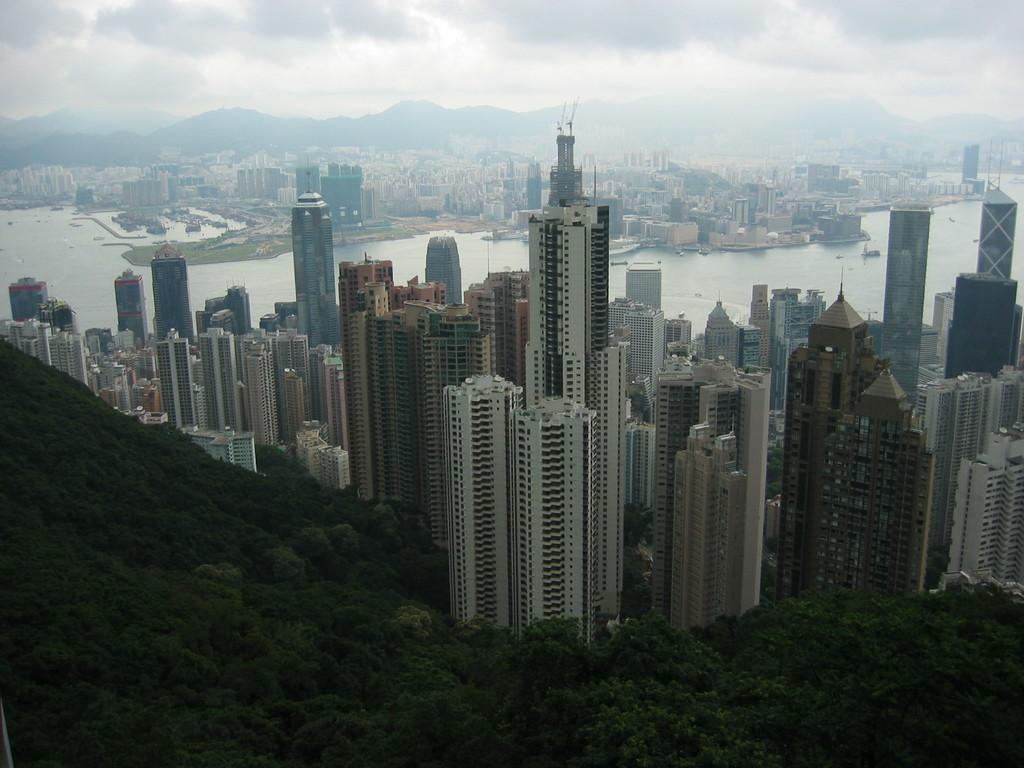How would you summarize this image in a sentence or two? In the image in the center we can see buildings,trees,water,plants,boats,wall etc. In the background we can see the sky,clouds and hill. 